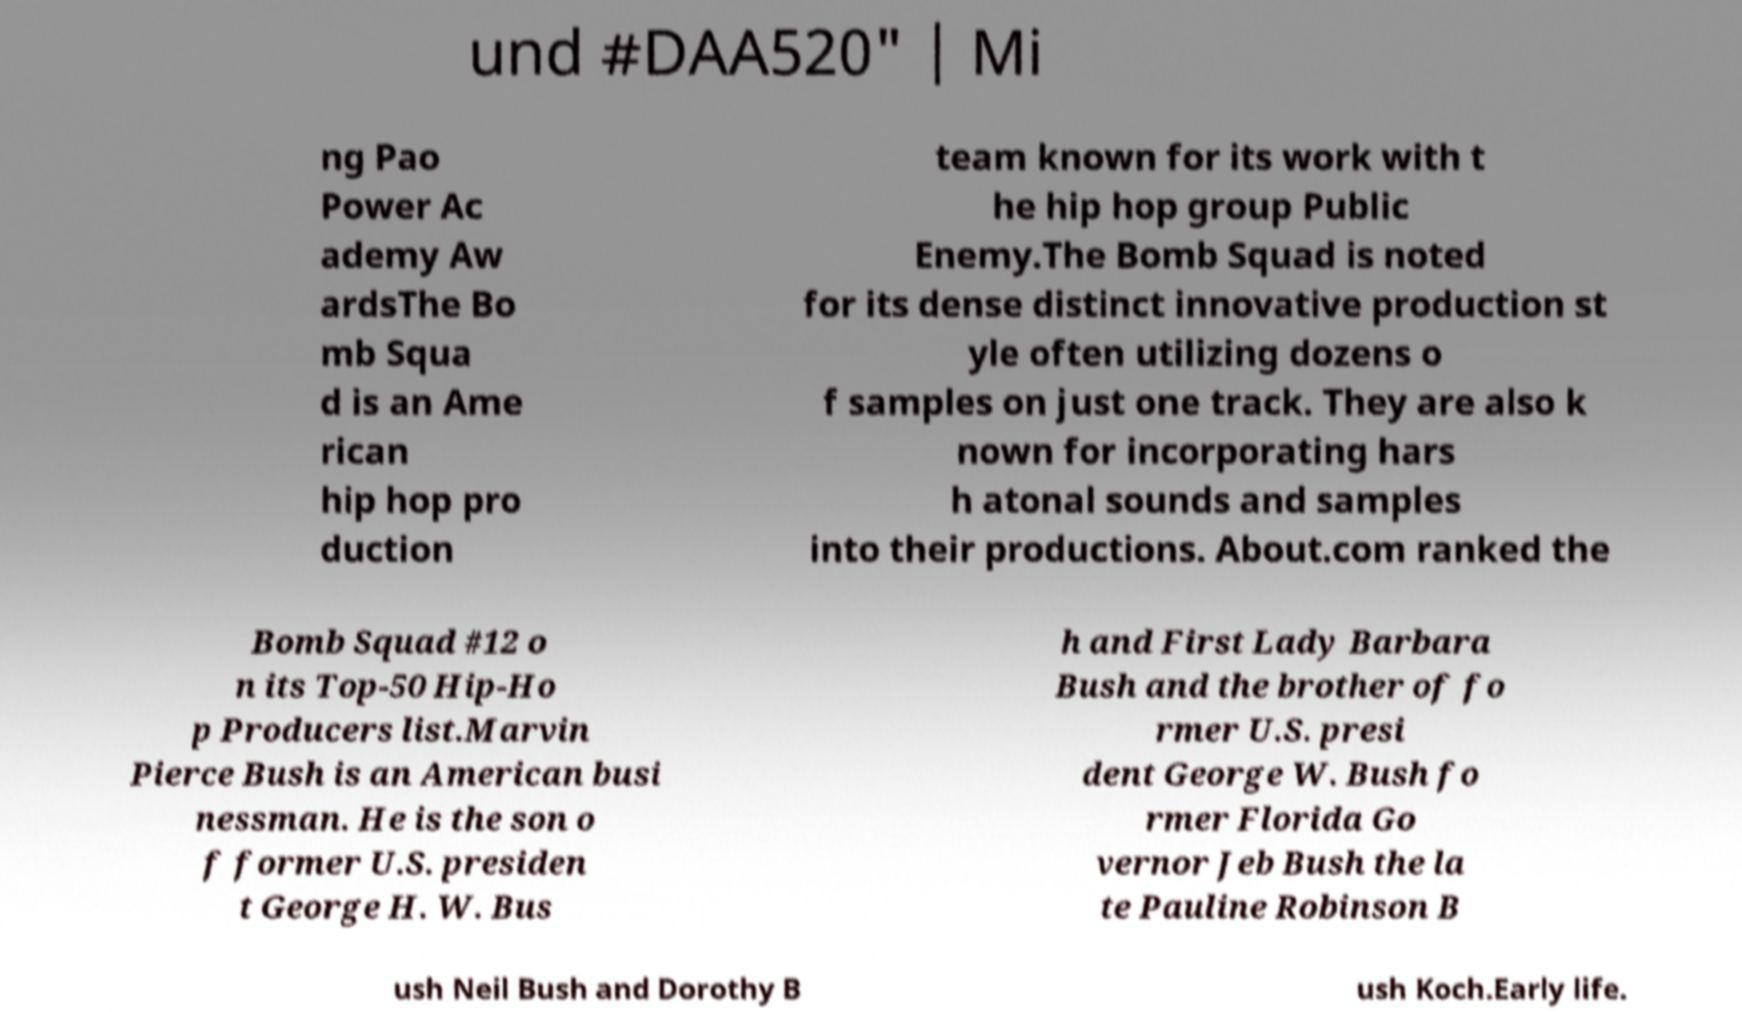What messages or text are displayed in this image? I need them in a readable, typed format. und #DAA520" | Mi ng Pao Power Ac ademy Aw ardsThe Bo mb Squa d is an Ame rican hip hop pro duction team known for its work with t he hip hop group Public Enemy.The Bomb Squad is noted for its dense distinct innovative production st yle often utilizing dozens o f samples on just one track. They are also k nown for incorporating hars h atonal sounds and samples into their productions. About.com ranked the Bomb Squad #12 o n its Top-50 Hip-Ho p Producers list.Marvin Pierce Bush is an American busi nessman. He is the son o f former U.S. presiden t George H. W. Bus h and First Lady Barbara Bush and the brother of fo rmer U.S. presi dent George W. Bush fo rmer Florida Go vernor Jeb Bush the la te Pauline Robinson B ush Neil Bush and Dorothy B ush Koch.Early life. 